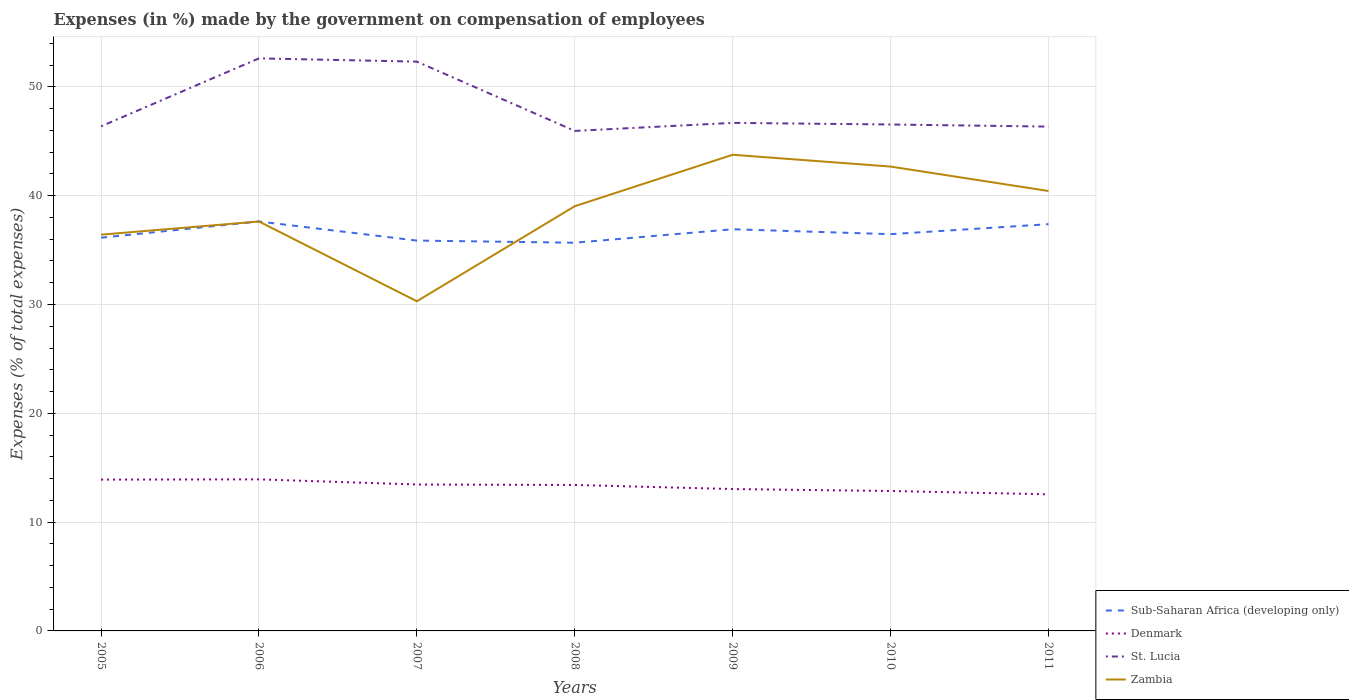How many different coloured lines are there?
Make the answer very short. 4. Is the number of lines equal to the number of legend labels?
Give a very brief answer. Yes. Across all years, what is the maximum percentage of expenses made by the government on compensation of employees in Sub-Saharan Africa (developing only)?
Make the answer very short. 35.68. In which year was the percentage of expenses made by the government on compensation of employees in Sub-Saharan Africa (developing only) maximum?
Provide a short and direct response. 2008. What is the total percentage of expenses made by the government on compensation of employees in St. Lucia in the graph?
Your answer should be compact. -0.17. What is the difference between the highest and the second highest percentage of expenses made by the government on compensation of employees in St. Lucia?
Your answer should be very brief. 6.67. What is the difference between the highest and the lowest percentage of expenses made by the government on compensation of employees in Denmark?
Ensure brevity in your answer.  4. How many years are there in the graph?
Provide a succinct answer. 7. Are the values on the major ticks of Y-axis written in scientific E-notation?
Provide a short and direct response. No. Does the graph contain grids?
Provide a succinct answer. Yes. How many legend labels are there?
Keep it short and to the point. 4. How are the legend labels stacked?
Make the answer very short. Vertical. What is the title of the graph?
Offer a very short reply. Expenses (in %) made by the government on compensation of employees. Does "Liechtenstein" appear as one of the legend labels in the graph?
Your answer should be very brief. No. What is the label or title of the X-axis?
Give a very brief answer. Years. What is the label or title of the Y-axis?
Provide a short and direct response. Expenses (% of total expenses). What is the Expenses (% of total expenses) in Sub-Saharan Africa (developing only) in 2005?
Your response must be concise. 36.14. What is the Expenses (% of total expenses) in Denmark in 2005?
Ensure brevity in your answer.  13.91. What is the Expenses (% of total expenses) of St. Lucia in 2005?
Ensure brevity in your answer.  46.38. What is the Expenses (% of total expenses) of Zambia in 2005?
Your answer should be compact. 36.42. What is the Expenses (% of total expenses) of Sub-Saharan Africa (developing only) in 2006?
Provide a succinct answer. 37.63. What is the Expenses (% of total expenses) in Denmark in 2006?
Provide a succinct answer. 13.93. What is the Expenses (% of total expenses) in St. Lucia in 2006?
Keep it short and to the point. 52.62. What is the Expenses (% of total expenses) in Zambia in 2006?
Keep it short and to the point. 37.63. What is the Expenses (% of total expenses) of Sub-Saharan Africa (developing only) in 2007?
Give a very brief answer. 35.87. What is the Expenses (% of total expenses) of Denmark in 2007?
Offer a very short reply. 13.46. What is the Expenses (% of total expenses) in St. Lucia in 2007?
Offer a terse response. 52.32. What is the Expenses (% of total expenses) of Zambia in 2007?
Make the answer very short. 30.3. What is the Expenses (% of total expenses) of Sub-Saharan Africa (developing only) in 2008?
Make the answer very short. 35.68. What is the Expenses (% of total expenses) of Denmark in 2008?
Your answer should be very brief. 13.41. What is the Expenses (% of total expenses) of St. Lucia in 2008?
Keep it short and to the point. 45.95. What is the Expenses (% of total expenses) of Zambia in 2008?
Provide a succinct answer. 39.03. What is the Expenses (% of total expenses) in Sub-Saharan Africa (developing only) in 2009?
Your answer should be very brief. 36.91. What is the Expenses (% of total expenses) of Denmark in 2009?
Your response must be concise. 13.04. What is the Expenses (% of total expenses) in St. Lucia in 2009?
Provide a short and direct response. 46.69. What is the Expenses (% of total expenses) of Zambia in 2009?
Your answer should be compact. 43.76. What is the Expenses (% of total expenses) of Sub-Saharan Africa (developing only) in 2010?
Your answer should be very brief. 36.46. What is the Expenses (% of total expenses) of Denmark in 2010?
Your response must be concise. 12.86. What is the Expenses (% of total expenses) of St. Lucia in 2010?
Ensure brevity in your answer.  46.54. What is the Expenses (% of total expenses) in Zambia in 2010?
Make the answer very short. 42.68. What is the Expenses (% of total expenses) in Sub-Saharan Africa (developing only) in 2011?
Offer a very short reply. 37.38. What is the Expenses (% of total expenses) of Denmark in 2011?
Offer a very short reply. 12.55. What is the Expenses (% of total expenses) of St. Lucia in 2011?
Keep it short and to the point. 46.35. What is the Expenses (% of total expenses) of Zambia in 2011?
Ensure brevity in your answer.  40.43. Across all years, what is the maximum Expenses (% of total expenses) of Sub-Saharan Africa (developing only)?
Offer a very short reply. 37.63. Across all years, what is the maximum Expenses (% of total expenses) of Denmark?
Offer a terse response. 13.93. Across all years, what is the maximum Expenses (% of total expenses) in St. Lucia?
Give a very brief answer. 52.62. Across all years, what is the maximum Expenses (% of total expenses) in Zambia?
Ensure brevity in your answer.  43.76. Across all years, what is the minimum Expenses (% of total expenses) in Sub-Saharan Africa (developing only)?
Offer a terse response. 35.68. Across all years, what is the minimum Expenses (% of total expenses) in Denmark?
Your response must be concise. 12.55. Across all years, what is the minimum Expenses (% of total expenses) in St. Lucia?
Keep it short and to the point. 45.95. Across all years, what is the minimum Expenses (% of total expenses) in Zambia?
Provide a succinct answer. 30.3. What is the total Expenses (% of total expenses) of Sub-Saharan Africa (developing only) in the graph?
Ensure brevity in your answer.  256.08. What is the total Expenses (% of total expenses) in Denmark in the graph?
Provide a succinct answer. 93.16. What is the total Expenses (% of total expenses) of St. Lucia in the graph?
Keep it short and to the point. 336.85. What is the total Expenses (% of total expenses) of Zambia in the graph?
Your response must be concise. 270.25. What is the difference between the Expenses (% of total expenses) of Sub-Saharan Africa (developing only) in 2005 and that in 2006?
Make the answer very short. -1.49. What is the difference between the Expenses (% of total expenses) of Denmark in 2005 and that in 2006?
Your answer should be very brief. -0.02. What is the difference between the Expenses (% of total expenses) of St. Lucia in 2005 and that in 2006?
Provide a short and direct response. -6.24. What is the difference between the Expenses (% of total expenses) in Zambia in 2005 and that in 2006?
Make the answer very short. -1.21. What is the difference between the Expenses (% of total expenses) in Sub-Saharan Africa (developing only) in 2005 and that in 2007?
Your answer should be compact. 0.26. What is the difference between the Expenses (% of total expenses) of Denmark in 2005 and that in 2007?
Give a very brief answer. 0.45. What is the difference between the Expenses (% of total expenses) of St. Lucia in 2005 and that in 2007?
Provide a short and direct response. -5.95. What is the difference between the Expenses (% of total expenses) of Zambia in 2005 and that in 2007?
Provide a succinct answer. 6.12. What is the difference between the Expenses (% of total expenses) of Sub-Saharan Africa (developing only) in 2005 and that in 2008?
Offer a very short reply. 0.46. What is the difference between the Expenses (% of total expenses) of Denmark in 2005 and that in 2008?
Make the answer very short. 0.49. What is the difference between the Expenses (% of total expenses) of St. Lucia in 2005 and that in 2008?
Give a very brief answer. 0.42. What is the difference between the Expenses (% of total expenses) of Zambia in 2005 and that in 2008?
Provide a short and direct response. -2.62. What is the difference between the Expenses (% of total expenses) in Sub-Saharan Africa (developing only) in 2005 and that in 2009?
Your response must be concise. -0.78. What is the difference between the Expenses (% of total expenses) of Denmark in 2005 and that in 2009?
Make the answer very short. 0.87. What is the difference between the Expenses (% of total expenses) of St. Lucia in 2005 and that in 2009?
Keep it short and to the point. -0.31. What is the difference between the Expenses (% of total expenses) of Zambia in 2005 and that in 2009?
Give a very brief answer. -7.34. What is the difference between the Expenses (% of total expenses) of Sub-Saharan Africa (developing only) in 2005 and that in 2010?
Your response must be concise. -0.33. What is the difference between the Expenses (% of total expenses) of Denmark in 2005 and that in 2010?
Your answer should be very brief. 1.05. What is the difference between the Expenses (% of total expenses) in St. Lucia in 2005 and that in 2010?
Keep it short and to the point. -0.17. What is the difference between the Expenses (% of total expenses) in Zambia in 2005 and that in 2010?
Make the answer very short. -6.26. What is the difference between the Expenses (% of total expenses) in Sub-Saharan Africa (developing only) in 2005 and that in 2011?
Provide a short and direct response. -1.24. What is the difference between the Expenses (% of total expenses) in Denmark in 2005 and that in 2011?
Your answer should be compact. 1.35. What is the difference between the Expenses (% of total expenses) in St. Lucia in 2005 and that in 2011?
Offer a terse response. 0.03. What is the difference between the Expenses (% of total expenses) in Zambia in 2005 and that in 2011?
Keep it short and to the point. -4.01. What is the difference between the Expenses (% of total expenses) in Sub-Saharan Africa (developing only) in 2006 and that in 2007?
Give a very brief answer. 1.75. What is the difference between the Expenses (% of total expenses) of Denmark in 2006 and that in 2007?
Offer a terse response. 0.47. What is the difference between the Expenses (% of total expenses) in St. Lucia in 2006 and that in 2007?
Your answer should be very brief. 0.3. What is the difference between the Expenses (% of total expenses) of Zambia in 2006 and that in 2007?
Offer a very short reply. 7.33. What is the difference between the Expenses (% of total expenses) in Sub-Saharan Africa (developing only) in 2006 and that in 2008?
Make the answer very short. 1.95. What is the difference between the Expenses (% of total expenses) of Denmark in 2006 and that in 2008?
Your response must be concise. 0.52. What is the difference between the Expenses (% of total expenses) of St. Lucia in 2006 and that in 2008?
Your answer should be compact. 6.67. What is the difference between the Expenses (% of total expenses) in Zambia in 2006 and that in 2008?
Offer a very short reply. -1.41. What is the difference between the Expenses (% of total expenses) of Sub-Saharan Africa (developing only) in 2006 and that in 2009?
Make the answer very short. 0.71. What is the difference between the Expenses (% of total expenses) of Denmark in 2006 and that in 2009?
Give a very brief answer. 0.89. What is the difference between the Expenses (% of total expenses) of St. Lucia in 2006 and that in 2009?
Your answer should be very brief. 5.93. What is the difference between the Expenses (% of total expenses) of Zambia in 2006 and that in 2009?
Your answer should be compact. -6.13. What is the difference between the Expenses (% of total expenses) in Sub-Saharan Africa (developing only) in 2006 and that in 2010?
Provide a succinct answer. 1.16. What is the difference between the Expenses (% of total expenses) in Denmark in 2006 and that in 2010?
Your answer should be very brief. 1.07. What is the difference between the Expenses (% of total expenses) of St. Lucia in 2006 and that in 2010?
Keep it short and to the point. 6.08. What is the difference between the Expenses (% of total expenses) in Zambia in 2006 and that in 2010?
Your answer should be compact. -5.05. What is the difference between the Expenses (% of total expenses) of Sub-Saharan Africa (developing only) in 2006 and that in 2011?
Provide a short and direct response. 0.25. What is the difference between the Expenses (% of total expenses) of Denmark in 2006 and that in 2011?
Your answer should be compact. 1.37. What is the difference between the Expenses (% of total expenses) in St. Lucia in 2006 and that in 2011?
Make the answer very short. 6.27. What is the difference between the Expenses (% of total expenses) of Zambia in 2006 and that in 2011?
Offer a very short reply. -2.8. What is the difference between the Expenses (% of total expenses) in Sub-Saharan Africa (developing only) in 2007 and that in 2008?
Your answer should be compact. 0.2. What is the difference between the Expenses (% of total expenses) in Denmark in 2007 and that in 2008?
Offer a very short reply. 0.04. What is the difference between the Expenses (% of total expenses) in St. Lucia in 2007 and that in 2008?
Offer a terse response. 6.37. What is the difference between the Expenses (% of total expenses) in Zambia in 2007 and that in 2008?
Ensure brevity in your answer.  -8.74. What is the difference between the Expenses (% of total expenses) in Sub-Saharan Africa (developing only) in 2007 and that in 2009?
Your answer should be very brief. -1.04. What is the difference between the Expenses (% of total expenses) in Denmark in 2007 and that in 2009?
Keep it short and to the point. 0.42. What is the difference between the Expenses (% of total expenses) in St. Lucia in 2007 and that in 2009?
Your answer should be compact. 5.63. What is the difference between the Expenses (% of total expenses) in Zambia in 2007 and that in 2009?
Offer a terse response. -13.46. What is the difference between the Expenses (% of total expenses) in Sub-Saharan Africa (developing only) in 2007 and that in 2010?
Offer a terse response. -0.59. What is the difference between the Expenses (% of total expenses) of Denmark in 2007 and that in 2010?
Offer a very short reply. 0.6. What is the difference between the Expenses (% of total expenses) of St. Lucia in 2007 and that in 2010?
Give a very brief answer. 5.78. What is the difference between the Expenses (% of total expenses) of Zambia in 2007 and that in 2010?
Your answer should be compact. -12.38. What is the difference between the Expenses (% of total expenses) in Sub-Saharan Africa (developing only) in 2007 and that in 2011?
Your response must be concise. -1.51. What is the difference between the Expenses (% of total expenses) in Denmark in 2007 and that in 2011?
Ensure brevity in your answer.  0.9. What is the difference between the Expenses (% of total expenses) in St. Lucia in 2007 and that in 2011?
Provide a succinct answer. 5.97. What is the difference between the Expenses (% of total expenses) of Zambia in 2007 and that in 2011?
Offer a very short reply. -10.13. What is the difference between the Expenses (% of total expenses) in Sub-Saharan Africa (developing only) in 2008 and that in 2009?
Offer a very short reply. -1.24. What is the difference between the Expenses (% of total expenses) in Denmark in 2008 and that in 2009?
Give a very brief answer. 0.38. What is the difference between the Expenses (% of total expenses) of St. Lucia in 2008 and that in 2009?
Ensure brevity in your answer.  -0.74. What is the difference between the Expenses (% of total expenses) of Zambia in 2008 and that in 2009?
Your answer should be very brief. -4.73. What is the difference between the Expenses (% of total expenses) in Sub-Saharan Africa (developing only) in 2008 and that in 2010?
Your response must be concise. -0.79. What is the difference between the Expenses (% of total expenses) in Denmark in 2008 and that in 2010?
Your answer should be compact. 0.55. What is the difference between the Expenses (% of total expenses) of St. Lucia in 2008 and that in 2010?
Your response must be concise. -0.59. What is the difference between the Expenses (% of total expenses) in Zambia in 2008 and that in 2010?
Provide a short and direct response. -3.64. What is the difference between the Expenses (% of total expenses) of Sub-Saharan Africa (developing only) in 2008 and that in 2011?
Your response must be concise. -1.7. What is the difference between the Expenses (% of total expenses) of Denmark in 2008 and that in 2011?
Provide a short and direct response. 0.86. What is the difference between the Expenses (% of total expenses) in St. Lucia in 2008 and that in 2011?
Provide a succinct answer. -0.4. What is the difference between the Expenses (% of total expenses) of Zambia in 2008 and that in 2011?
Ensure brevity in your answer.  -1.4. What is the difference between the Expenses (% of total expenses) in Sub-Saharan Africa (developing only) in 2009 and that in 2010?
Give a very brief answer. 0.45. What is the difference between the Expenses (% of total expenses) in Denmark in 2009 and that in 2010?
Keep it short and to the point. 0.18. What is the difference between the Expenses (% of total expenses) in St. Lucia in 2009 and that in 2010?
Your answer should be compact. 0.15. What is the difference between the Expenses (% of total expenses) of Zambia in 2009 and that in 2010?
Provide a short and direct response. 1.08. What is the difference between the Expenses (% of total expenses) of Sub-Saharan Africa (developing only) in 2009 and that in 2011?
Your answer should be very brief. -0.47. What is the difference between the Expenses (% of total expenses) in Denmark in 2009 and that in 2011?
Give a very brief answer. 0.48. What is the difference between the Expenses (% of total expenses) of St. Lucia in 2009 and that in 2011?
Provide a succinct answer. 0.34. What is the difference between the Expenses (% of total expenses) in Zambia in 2009 and that in 2011?
Your answer should be very brief. 3.33. What is the difference between the Expenses (% of total expenses) in Sub-Saharan Africa (developing only) in 2010 and that in 2011?
Provide a succinct answer. -0.92. What is the difference between the Expenses (% of total expenses) of Denmark in 2010 and that in 2011?
Provide a succinct answer. 0.31. What is the difference between the Expenses (% of total expenses) of St. Lucia in 2010 and that in 2011?
Provide a short and direct response. 0.19. What is the difference between the Expenses (% of total expenses) of Zambia in 2010 and that in 2011?
Offer a very short reply. 2.24. What is the difference between the Expenses (% of total expenses) of Sub-Saharan Africa (developing only) in 2005 and the Expenses (% of total expenses) of Denmark in 2006?
Offer a very short reply. 22.21. What is the difference between the Expenses (% of total expenses) in Sub-Saharan Africa (developing only) in 2005 and the Expenses (% of total expenses) in St. Lucia in 2006?
Make the answer very short. -16.48. What is the difference between the Expenses (% of total expenses) in Sub-Saharan Africa (developing only) in 2005 and the Expenses (% of total expenses) in Zambia in 2006?
Your answer should be very brief. -1.49. What is the difference between the Expenses (% of total expenses) in Denmark in 2005 and the Expenses (% of total expenses) in St. Lucia in 2006?
Your answer should be very brief. -38.71. What is the difference between the Expenses (% of total expenses) in Denmark in 2005 and the Expenses (% of total expenses) in Zambia in 2006?
Provide a succinct answer. -23.72. What is the difference between the Expenses (% of total expenses) in St. Lucia in 2005 and the Expenses (% of total expenses) in Zambia in 2006?
Ensure brevity in your answer.  8.75. What is the difference between the Expenses (% of total expenses) of Sub-Saharan Africa (developing only) in 2005 and the Expenses (% of total expenses) of Denmark in 2007?
Ensure brevity in your answer.  22.68. What is the difference between the Expenses (% of total expenses) in Sub-Saharan Africa (developing only) in 2005 and the Expenses (% of total expenses) in St. Lucia in 2007?
Offer a terse response. -16.19. What is the difference between the Expenses (% of total expenses) of Sub-Saharan Africa (developing only) in 2005 and the Expenses (% of total expenses) of Zambia in 2007?
Make the answer very short. 5.84. What is the difference between the Expenses (% of total expenses) of Denmark in 2005 and the Expenses (% of total expenses) of St. Lucia in 2007?
Ensure brevity in your answer.  -38.41. What is the difference between the Expenses (% of total expenses) of Denmark in 2005 and the Expenses (% of total expenses) of Zambia in 2007?
Make the answer very short. -16.39. What is the difference between the Expenses (% of total expenses) in St. Lucia in 2005 and the Expenses (% of total expenses) in Zambia in 2007?
Give a very brief answer. 16.08. What is the difference between the Expenses (% of total expenses) in Sub-Saharan Africa (developing only) in 2005 and the Expenses (% of total expenses) in Denmark in 2008?
Your answer should be compact. 22.72. What is the difference between the Expenses (% of total expenses) in Sub-Saharan Africa (developing only) in 2005 and the Expenses (% of total expenses) in St. Lucia in 2008?
Provide a succinct answer. -9.81. What is the difference between the Expenses (% of total expenses) in Sub-Saharan Africa (developing only) in 2005 and the Expenses (% of total expenses) in Zambia in 2008?
Give a very brief answer. -2.9. What is the difference between the Expenses (% of total expenses) in Denmark in 2005 and the Expenses (% of total expenses) in St. Lucia in 2008?
Provide a short and direct response. -32.04. What is the difference between the Expenses (% of total expenses) in Denmark in 2005 and the Expenses (% of total expenses) in Zambia in 2008?
Provide a short and direct response. -25.13. What is the difference between the Expenses (% of total expenses) of St. Lucia in 2005 and the Expenses (% of total expenses) of Zambia in 2008?
Your answer should be very brief. 7.34. What is the difference between the Expenses (% of total expenses) in Sub-Saharan Africa (developing only) in 2005 and the Expenses (% of total expenses) in Denmark in 2009?
Give a very brief answer. 23.1. What is the difference between the Expenses (% of total expenses) of Sub-Saharan Africa (developing only) in 2005 and the Expenses (% of total expenses) of St. Lucia in 2009?
Offer a terse response. -10.55. What is the difference between the Expenses (% of total expenses) in Sub-Saharan Africa (developing only) in 2005 and the Expenses (% of total expenses) in Zambia in 2009?
Your answer should be very brief. -7.62. What is the difference between the Expenses (% of total expenses) of Denmark in 2005 and the Expenses (% of total expenses) of St. Lucia in 2009?
Keep it short and to the point. -32.78. What is the difference between the Expenses (% of total expenses) in Denmark in 2005 and the Expenses (% of total expenses) in Zambia in 2009?
Offer a terse response. -29.85. What is the difference between the Expenses (% of total expenses) in St. Lucia in 2005 and the Expenses (% of total expenses) in Zambia in 2009?
Your answer should be very brief. 2.62. What is the difference between the Expenses (% of total expenses) of Sub-Saharan Africa (developing only) in 2005 and the Expenses (% of total expenses) of Denmark in 2010?
Your answer should be compact. 23.28. What is the difference between the Expenses (% of total expenses) of Sub-Saharan Africa (developing only) in 2005 and the Expenses (% of total expenses) of St. Lucia in 2010?
Give a very brief answer. -10.41. What is the difference between the Expenses (% of total expenses) in Sub-Saharan Africa (developing only) in 2005 and the Expenses (% of total expenses) in Zambia in 2010?
Make the answer very short. -6.54. What is the difference between the Expenses (% of total expenses) in Denmark in 2005 and the Expenses (% of total expenses) in St. Lucia in 2010?
Keep it short and to the point. -32.64. What is the difference between the Expenses (% of total expenses) in Denmark in 2005 and the Expenses (% of total expenses) in Zambia in 2010?
Your answer should be very brief. -28.77. What is the difference between the Expenses (% of total expenses) in St. Lucia in 2005 and the Expenses (% of total expenses) in Zambia in 2010?
Provide a succinct answer. 3.7. What is the difference between the Expenses (% of total expenses) of Sub-Saharan Africa (developing only) in 2005 and the Expenses (% of total expenses) of Denmark in 2011?
Make the answer very short. 23.58. What is the difference between the Expenses (% of total expenses) of Sub-Saharan Africa (developing only) in 2005 and the Expenses (% of total expenses) of St. Lucia in 2011?
Your answer should be very brief. -10.21. What is the difference between the Expenses (% of total expenses) of Sub-Saharan Africa (developing only) in 2005 and the Expenses (% of total expenses) of Zambia in 2011?
Ensure brevity in your answer.  -4.29. What is the difference between the Expenses (% of total expenses) in Denmark in 2005 and the Expenses (% of total expenses) in St. Lucia in 2011?
Provide a short and direct response. -32.44. What is the difference between the Expenses (% of total expenses) in Denmark in 2005 and the Expenses (% of total expenses) in Zambia in 2011?
Make the answer very short. -26.52. What is the difference between the Expenses (% of total expenses) of St. Lucia in 2005 and the Expenses (% of total expenses) of Zambia in 2011?
Your response must be concise. 5.95. What is the difference between the Expenses (% of total expenses) in Sub-Saharan Africa (developing only) in 2006 and the Expenses (% of total expenses) in Denmark in 2007?
Offer a very short reply. 24.17. What is the difference between the Expenses (% of total expenses) of Sub-Saharan Africa (developing only) in 2006 and the Expenses (% of total expenses) of St. Lucia in 2007?
Provide a succinct answer. -14.69. What is the difference between the Expenses (% of total expenses) of Sub-Saharan Africa (developing only) in 2006 and the Expenses (% of total expenses) of Zambia in 2007?
Provide a succinct answer. 7.33. What is the difference between the Expenses (% of total expenses) of Denmark in 2006 and the Expenses (% of total expenses) of St. Lucia in 2007?
Offer a very short reply. -38.39. What is the difference between the Expenses (% of total expenses) in Denmark in 2006 and the Expenses (% of total expenses) in Zambia in 2007?
Your response must be concise. -16.37. What is the difference between the Expenses (% of total expenses) of St. Lucia in 2006 and the Expenses (% of total expenses) of Zambia in 2007?
Make the answer very short. 22.32. What is the difference between the Expenses (% of total expenses) in Sub-Saharan Africa (developing only) in 2006 and the Expenses (% of total expenses) in Denmark in 2008?
Ensure brevity in your answer.  24.21. What is the difference between the Expenses (% of total expenses) of Sub-Saharan Africa (developing only) in 2006 and the Expenses (% of total expenses) of St. Lucia in 2008?
Your response must be concise. -8.32. What is the difference between the Expenses (% of total expenses) of Sub-Saharan Africa (developing only) in 2006 and the Expenses (% of total expenses) of Zambia in 2008?
Ensure brevity in your answer.  -1.41. What is the difference between the Expenses (% of total expenses) of Denmark in 2006 and the Expenses (% of total expenses) of St. Lucia in 2008?
Give a very brief answer. -32.02. What is the difference between the Expenses (% of total expenses) in Denmark in 2006 and the Expenses (% of total expenses) in Zambia in 2008?
Offer a very short reply. -25.11. What is the difference between the Expenses (% of total expenses) in St. Lucia in 2006 and the Expenses (% of total expenses) in Zambia in 2008?
Offer a terse response. 13.58. What is the difference between the Expenses (% of total expenses) in Sub-Saharan Africa (developing only) in 2006 and the Expenses (% of total expenses) in Denmark in 2009?
Keep it short and to the point. 24.59. What is the difference between the Expenses (% of total expenses) of Sub-Saharan Africa (developing only) in 2006 and the Expenses (% of total expenses) of St. Lucia in 2009?
Your answer should be compact. -9.06. What is the difference between the Expenses (% of total expenses) of Sub-Saharan Africa (developing only) in 2006 and the Expenses (% of total expenses) of Zambia in 2009?
Your answer should be compact. -6.13. What is the difference between the Expenses (% of total expenses) of Denmark in 2006 and the Expenses (% of total expenses) of St. Lucia in 2009?
Provide a short and direct response. -32.76. What is the difference between the Expenses (% of total expenses) in Denmark in 2006 and the Expenses (% of total expenses) in Zambia in 2009?
Your answer should be compact. -29.83. What is the difference between the Expenses (% of total expenses) in St. Lucia in 2006 and the Expenses (% of total expenses) in Zambia in 2009?
Make the answer very short. 8.86. What is the difference between the Expenses (% of total expenses) in Sub-Saharan Africa (developing only) in 2006 and the Expenses (% of total expenses) in Denmark in 2010?
Ensure brevity in your answer.  24.77. What is the difference between the Expenses (% of total expenses) in Sub-Saharan Africa (developing only) in 2006 and the Expenses (% of total expenses) in St. Lucia in 2010?
Keep it short and to the point. -8.91. What is the difference between the Expenses (% of total expenses) in Sub-Saharan Africa (developing only) in 2006 and the Expenses (% of total expenses) in Zambia in 2010?
Give a very brief answer. -5.05. What is the difference between the Expenses (% of total expenses) of Denmark in 2006 and the Expenses (% of total expenses) of St. Lucia in 2010?
Provide a short and direct response. -32.61. What is the difference between the Expenses (% of total expenses) of Denmark in 2006 and the Expenses (% of total expenses) of Zambia in 2010?
Provide a succinct answer. -28.75. What is the difference between the Expenses (% of total expenses) of St. Lucia in 2006 and the Expenses (% of total expenses) of Zambia in 2010?
Your answer should be compact. 9.94. What is the difference between the Expenses (% of total expenses) of Sub-Saharan Africa (developing only) in 2006 and the Expenses (% of total expenses) of Denmark in 2011?
Your response must be concise. 25.07. What is the difference between the Expenses (% of total expenses) of Sub-Saharan Africa (developing only) in 2006 and the Expenses (% of total expenses) of St. Lucia in 2011?
Your response must be concise. -8.72. What is the difference between the Expenses (% of total expenses) of Sub-Saharan Africa (developing only) in 2006 and the Expenses (% of total expenses) of Zambia in 2011?
Keep it short and to the point. -2.8. What is the difference between the Expenses (% of total expenses) in Denmark in 2006 and the Expenses (% of total expenses) in St. Lucia in 2011?
Provide a short and direct response. -32.42. What is the difference between the Expenses (% of total expenses) in Denmark in 2006 and the Expenses (% of total expenses) in Zambia in 2011?
Your answer should be very brief. -26.5. What is the difference between the Expenses (% of total expenses) in St. Lucia in 2006 and the Expenses (% of total expenses) in Zambia in 2011?
Your answer should be compact. 12.19. What is the difference between the Expenses (% of total expenses) in Sub-Saharan Africa (developing only) in 2007 and the Expenses (% of total expenses) in Denmark in 2008?
Your answer should be very brief. 22.46. What is the difference between the Expenses (% of total expenses) of Sub-Saharan Africa (developing only) in 2007 and the Expenses (% of total expenses) of St. Lucia in 2008?
Your response must be concise. -10.08. What is the difference between the Expenses (% of total expenses) in Sub-Saharan Africa (developing only) in 2007 and the Expenses (% of total expenses) in Zambia in 2008?
Your answer should be very brief. -3.16. What is the difference between the Expenses (% of total expenses) in Denmark in 2007 and the Expenses (% of total expenses) in St. Lucia in 2008?
Give a very brief answer. -32.49. What is the difference between the Expenses (% of total expenses) in Denmark in 2007 and the Expenses (% of total expenses) in Zambia in 2008?
Your answer should be compact. -25.58. What is the difference between the Expenses (% of total expenses) in St. Lucia in 2007 and the Expenses (% of total expenses) in Zambia in 2008?
Offer a very short reply. 13.29. What is the difference between the Expenses (% of total expenses) in Sub-Saharan Africa (developing only) in 2007 and the Expenses (% of total expenses) in Denmark in 2009?
Provide a short and direct response. 22.84. What is the difference between the Expenses (% of total expenses) in Sub-Saharan Africa (developing only) in 2007 and the Expenses (% of total expenses) in St. Lucia in 2009?
Give a very brief answer. -10.82. What is the difference between the Expenses (% of total expenses) in Sub-Saharan Africa (developing only) in 2007 and the Expenses (% of total expenses) in Zambia in 2009?
Give a very brief answer. -7.89. What is the difference between the Expenses (% of total expenses) of Denmark in 2007 and the Expenses (% of total expenses) of St. Lucia in 2009?
Your answer should be compact. -33.23. What is the difference between the Expenses (% of total expenses) in Denmark in 2007 and the Expenses (% of total expenses) in Zambia in 2009?
Provide a succinct answer. -30.3. What is the difference between the Expenses (% of total expenses) in St. Lucia in 2007 and the Expenses (% of total expenses) in Zambia in 2009?
Offer a terse response. 8.56. What is the difference between the Expenses (% of total expenses) of Sub-Saharan Africa (developing only) in 2007 and the Expenses (% of total expenses) of Denmark in 2010?
Offer a very short reply. 23.01. What is the difference between the Expenses (% of total expenses) in Sub-Saharan Africa (developing only) in 2007 and the Expenses (% of total expenses) in St. Lucia in 2010?
Provide a short and direct response. -10.67. What is the difference between the Expenses (% of total expenses) in Sub-Saharan Africa (developing only) in 2007 and the Expenses (% of total expenses) in Zambia in 2010?
Your answer should be compact. -6.8. What is the difference between the Expenses (% of total expenses) of Denmark in 2007 and the Expenses (% of total expenses) of St. Lucia in 2010?
Offer a very short reply. -33.09. What is the difference between the Expenses (% of total expenses) in Denmark in 2007 and the Expenses (% of total expenses) in Zambia in 2010?
Offer a very short reply. -29.22. What is the difference between the Expenses (% of total expenses) of St. Lucia in 2007 and the Expenses (% of total expenses) of Zambia in 2010?
Provide a succinct answer. 9.65. What is the difference between the Expenses (% of total expenses) of Sub-Saharan Africa (developing only) in 2007 and the Expenses (% of total expenses) of Denmark in 2011?
Offer a terse response. 23.32. What is the difference between the Expenses (% of total expenses) in Sub-Saharan Africa (developing only) in 2007 and the Expenses (% of total expenses) in St. Lucia in 2011?
Provide a short and direct response. -10.48. What is the difference between the Expenses (% of total expenses) of Sub-Saharan Africa (developing only) in 2007 and the Expenses (% of total expenses) of Zambia in 2011?
Your answer should be very brief. -4.56. What is the difference between the Expenses (% of total expenses) in Denmark in 2007 and the Expenses (% of total expenses) in St. Lucia in 2011?
Provide a succinct answer. -32.89. What is the difference between the Expenses (% of total expenses) in Denmark in 2007 and the Expenses (% of total expenses) in Zambia in 2011?
Provide a succinct answer. -26.97. What is the difference between the Expenses (% of total expenses) of St. Lucia in 2007 and the Expenses (% of total expenses) of Zambia in 2011?
Provide a succinct answer. 11.89. What is the difference between the Expenses (% of total expenses) in Sub-Saharan Africa (developing only) in 2008 and the Expenses (% of total expenses) in Denmark in 2009?
Your answer should be compact. 22.64. What is the difference between the Expenses (% of total expenses) of Sub-Saharan Africa (developing only) in 2008 and the Expenses (% of total expenses) of St. Lucia in 2009?
Offer a very short reply. -11.01. What is the difference between the Expenses (% of total expenses) of Sub-Saharan Africa (developing only) in 2008 and the Expenses (% of total expenses) of Zambia in 2009?
Provide a short and direct response. -8.08. What is the difference between the Expenses (% of total expenses) of Denmark in 2008 and the Expenses (% of total expenses) of St. Lucia in 2009?
Keep it short and to the point. -33.28. What is the difference between the Expenses (% of total expenses) in Denmark in 2008 and the Expenses (% of total expenses) in Zambia in 2009?
Make the answer very short. -30.35. What is the difference between the Expenses (% of total expenses) in St. Lucia in 2008 and the Expenses (% of total expenses) in Zambia in 2009?
Offer a very short reply. 2.19. What is the difference between the Expenses (% of total expenses) in Sub-Saharan Africa (developing only) in 2008 and the Expenses (% of total expenses) in Denmark in 2010?
Your response must be concise. 22.82. What is the difference between the Expenses (% of total expenses) of Sub-Saharan Africa (developing only) in 2008 and the Expenses (% of total expenses) of St. Lucia in 2010?
Your answer should be very brief. -10.87. What is the difference between the Expenses (% of total expenses) of Sub-Saharan Africa (developing only) in 2008 and the Expenses (% of total expenses) of Zambia in 2010?
Offer a terse response. -7. What is the difference between the Expenses (% of total expenses) of Denmark in 2008 and the Expenses (% of total expenses) of St. Lucia in 2010?
Ensure brevity in your answer.  -33.13. What is the difference between the Expenses (% of total expenses) of Denmark in 2008 and the Expenses (% of total expenses) of Zambia in 2010?
Keep it short and to the point. -29.26. What is the difference between the Expenses (% of total expenses) in St. Lucia in 2008 and the Expenses (% of total expenses) in Zambia in 2010?
Keep it short and to the point. 3.28. What is the difference between the Expenses (% of total expenses) of Sub-Saharan Africa (developing only) in 2008 and the Expenses (% of total expenses) of Denmark in 2011?
Offer a very short reply. 23.12. What is the difference between the Expenses (% of total expenses) in Sub-Saharan Africa (developing only) in 2008 and the Expenses (% of total expenses) in St. Lucia in 2011?
Make the answer very short. -10.67. What is the difference between the Expenses (% of total expenses) of Sub-Saharan Africa (developing only) in 2008 and the Expenses (% of total expenses) of Zambia in 2011?
Make the answer very short. -4.75. What is the difference between the Expenses (% of total expenses) in Denmark in 2008 and the Expenses (% of total expenses) in St. Lucia in 2011?
Your answer should be compact. -32.94. What is the difference between the Expenses (% of total expenses) in Denmark in 2008 and the Expenses (% of total expenses) in Zambia in 2011?
Offer a very short reply. -27.02. What is the difference between the Expenses (% of total expenses) in St. Lucia in 2008 and the Expenses (% of total expenses) in Zambia in 2011?
Make the answer very short. 5.52. What is the difference between the Expenses (% of total expenses) in Sub-Saharan Africa (developing only) in 2009 and the Expenses (% of total expenses) in Denmark in 2010?
Ensure brevity in your answer.  24.05. What is the difference between the Expenses (% of total expenses) in Sub-Saharan Africa (developing only) in 2009 and the Expenses (% of total expenses) in St. Lucia in 2010?
Offer a very short reply. -9.63. What is the difference between the Expenses (% of total expenses) of Sub-Saharan Africa (developing only) in 2009 and the Expenses (% of total expenses) of Zambia in 2010?
Keep it short and to the point. -5.76. What is the difference between the Expenses (% of total expenses) of Denmark in 2009 and the Expenses (% of total expenses) of St. Lucia in 2010?
Give a very brief answer. -33.51. What is the difference between the Expenses (% of total expenses) in Denmark in 2009 and the Expenses (% of total expenses) in Zambia in 2010?
Your response must be concise. -29.64. What is the difference between the Expenses (% of total expenses) of St. Lucia in 2009 and the Expenses (% of total expenses) of Zambia in 2010?
Provide a succinct answer. 4.01. What is the difference between the Expenses (% of total expenses) in Sub-Saharan Africa (developing only) in 2009 and the Expenses (% of total expenses) in Denmark in 2011?
Offer a very short reply. 24.36. What is the difference between the Expenses (% of total expenses) in Sub-Saharan Africa (developing only) in 2009 and the Expenses (% of total expenses) in St. Lucia in 2011?
Ensure brevity in your answer.  -9.44. What is the difference between the Expenses (% of total expenses) in Sub-Saharan Africa (developing only) in 2009 and the Expenses (% of total expenses) in Zambia in 2011?
Give a very brief answer. -3.52. What is the difference between the Expenses (% of total expenses) of Denmark in 2009 and the Expenses (% of total expenses) of St. Lucia in 2011?
Provide a succinct answer. -33.31. What is the difference between the Expenses (% of total expenses) of Denmark in 2009 and the Expenses (% of total expenses) of Zambia in 2011?
Offer a terse response. -27.39. What is the difference between the Expenses (% of total expenses) in St. Lucia in 2009 and the Expenses (% of total expenses) in Zambia in 2011?
Offer a terse response. 6.26. What is the difference between the Expenses (% of total expenses) in Sub-Saharan Africa (developing only) in 2010 and the Expenses (% of total expenses) in Denmark in 2011?
Give a very brief answer. 23.91. What is the difference between the Expenses (% of total expenses) of Sub-Saharan Africa (developing only) in 2010 and the Expenses (% of total expenses) of St. Lucia in 2011?
Give a very brief answer. -9.89. What is the difference between the Expenses (% of total expenses) of Sub-Saharan Africa (developing only) in 2010 and the Expenses (% of total expenses) of Zambia in 2011?
Your answer should be very brief. -3.97. What is the difference between the Expenses (% of total expenses) of Denmark in 2010 and the Expenses (% of total expenses) of St. Lucia in 2011?
Provide a succinct answer. -33.49. What is the difference between the Expenses (% of total expenses) of Denmark in 2010 and the Expenses (% of total expenses) of Zambia in 2011?
Offer a very short reply. -27.57. What is the difference between the Expenses (% of total expenses) of St. Lucia in 2010 and the Expenses (% of total expenses) of Zambia in 2011?
Ensure brevity in your answer.  6.11. What is the average Expenses (% of total expenses) of Sub-Saharan Africa (developing only) per year?
Make the answer very short. 36.58. What is the average Expenses (% of total expenses) in Denmark per year?
Your answer should be compact. 13.31. What is the average Expenses (% of total expenses) in St. Lucia per year?
Offer a very short reply. 48.12. What is the average Expenses (% of total expenses) of Zambia per year?
Your answer should be very brief. 38.61. In the year 2005, what is the difference between the Expenses (% of total expenses) of Sub-Saharan Africa (developing only) and Expenses (% of total expenses) of Denmark?
Your answer should be very brief. 22.23. In the year 2005, what is the difference between the Expenses (% of total expenses) in Sub-Saharan Africa (developing only) and Expenses (% of total expenses) in St. Lucia?
Ensure brevity in your answer.  -10.24. In the year 2005, what is the difference between the Expenses (% of total expenses) of Sub-Saharan Africa (developing only) and Expenses (% of total expenses) of Zambia?
Your response must be concise. -0.28. In the year 2005, what is the difference between the Expenses (% of total expenses) in Denmark and Expenses (% of total expenses) in St. Lucia?
Your response must be concise. -32.47. In the year 2005, what is the difference between the Expenses (% of total expenses) of Denmark and Expenses (% of total expenses) of Zambia?
Provide a short and direct response. -22.51. In the year 2005, what is the difference between the Expenses (% of total expenses) in St. Lucia and Expenses (% of total expenses) in Zambia?
Ensure brevity in your answer.  9.96. In the year 2006, what is the difference between the Expenses (% of total expenses) in Sub-Saharan Africa (developing only) and Expenses (% of total expenses) in Denmark?
Make the answer very short. 23.7. In the year 2006, what is the difference between the Expenses (% of total expenses) in Sub-Saharan Africa (developing only) and Expenses (% of total expenses) in St. Lucia?
Ensure brevity in your answer.  -14.99. In the year 2006, what is the difference between the Expenses (% of total expenses) in Denmark and Expenses (% of total expenses) in St. Lucia?
Your answer should be compact. -38.69. In the year 2006, what is the difference between the Expenses (% of total expenses) of Denmark and Expenses (% of total expenses) of Zambia?
Offer a very short reply. -23.7. In the year 2006, what is the difference between the Expenses (% of total expenses) in St. Lucia and Expenses (% of total expenses) in Zambia?
Offer a very short reply. 14.99. In the year 2007, what is the difference between the Expenses (% of total expenses) of Sub-Saharan Africa (developing only) and Expenses (% of total expenses) of Denmark?
Make the answer very short. 22.42. In the year 2007, what is the difference between the Expenses (% of total expenses) of Sub-Saharan Africa (developing only) and Expenses (% of total expenses) of St. Lucia?
Your answer should be very brief. -16.45. In the year 2007, what is the difference between the Expenses (% of total expenses) of Sub-Saharan Africa (developing only) and Expenses (% of total expenses) of Zambia?
Your answer should be compact. 5.57. In the year 2007, what is the difference between the Expenses (% of total expenses) of Denmark and Expenses (% of total expenses) of St. Lucia?
Your answer should be very brief. -38.86. In the year 2007, what is the difference between the Expenses (% of total expenses) of Denmark and Expenses (% of total expenses) of Zambia?
Your answer should be very brief. -16.84. In the year 2007, what is the difference between the Expenses (% of total expenses) in St. Lucia and Expenses (% of total expenses) in Zambia?
Make the answer very short. 22.02. In the year 2008, what is the difference between the Expenses (% of total expenses) of Sub-Saharan Africa (developing only) and Expenses (% of total expenses) of Denmark?
Keep it short and to the point. 22.26. In the year 2008, what is the difference between the Expenses (% of total expenses) in Sub-Saharan Africa (developing only) and Expenses (% of total expenses) in St. Lucia?
Your response must be concise. -10.27. In the year 2008, what is the difference between the Expenses (% of total expenses) in Sub-Saharan Africa (developing only) and Expenses (% of total expenses) in Zambia?
Offer a terse response. -3.36. In the year 2008, what is the difference between the Expenses (% of total expenses) of Denmark and Expenses (% of total expenses) of St. Lucia?
Offer a very short reply. -32.54. In the year 2008, what is the difference between the Expenses (% of total expenses) in Denmark and Expenses (% of total expenses) in Zambia?
Your response must be concise. -25.62. In the year 2008, what is the difference between the Expenses (% of total expenses) of St. Lucia and Expenses (% of total expenses) of Zambia?
Offer a very short reply. 6.92. In the year 2009, what is the difference between the Expenses (% of total expenses) of Sub-Saharan Africa (developing only) and Expenses (% of total expenses) of Denmark?
Give a very brief answer. 23.88. In the year 2009, what is the difference between the Expenses (% of total expenses) in Sub-Saharan Africa (developing only) and Expenses (% of total expenses) in St. Lucia?
Provide a short and direct response. -9.78. In the year 2009, what is the difference between the Expenses (% of total expenses) in Sub-Saharan Africa (developing only) and Expenses (% of total expenses) in Zambia?
Make the answer very short. -6.85. In the year 2009, what is the difference between the Expenses (% of total expenses) in Denmark and Expenses (% of total expenses) in St. Lucia?
Ensure brevity in your answer.  -33.65. In the year 2009, what is the difference between the Expenses (% of total expenses) of Denmark and Expenses (% of total expenses) of Zambia?
Offer a very short reply. -30.72. In the year 2009, what is the difference between the Expenses (% of total expenses) in St. Lucia and Expenses (% of total expenses) in Zambia?
Provide a short and direct response. 2.93. In the year 2010, what is the difference between the Expenses (% of total expenses) in Sub-Saharan Africa (developing only) and Expenses (% of total expenses) in Denmark?
Provide a short and direct response. 23.6. In the year 2010, what is the difference between the Expenses (% of total expenses) of Sub-Saharan Africa (developing only) and Expenses (% of total expenses) of St. Lucia?
Your response must be concise. -10.08. In the year 2010, what is the difference between the Expenses (% of total expenses) of Sub-Saharan Africa (developing only) and Expenses (% of total expenses) of Zambia?
Keep it short and to the point. -6.21. In the year 2010, what is the difference between the Expenses (% of total expenses) of Denmark and Expenses (% of total expenses) of St. Lucia?
Offer a terse response. -33.68. In the year 2010, what is the difference between the Expenses (% of total expenses) in Denmark and Expenses (% of total expenses) in Zambia?
Your response must be concise. -29.82. In the year 2010, what is the difference between the Expenses (% of total expenses) in St. Lucia and Expenses (% of total expenses) in Zambia?
Ensure brevity in your answer.  3.87. In the year 2011, what is the difference between the Expenses (% of total expenses) in Sub-Saharan Africa (developing only) and Expenses (% of total expenses) in Denmark?
Offer a terse response. 24.83. In the year 2011, what is the difference between the Expenses (% of total expenses) in Sub-Saharan Africa (developing only) and Expenses (% of total expenses) in St. Lucia?
Your answer should be very brief. -8.97. In the year 2011, what is the difference between the Expenses (% of total expenses) of Sub-Saharan Africa (developing only) and Expenses (% of total expenses) of Zambia?
Provide a short and direct response. -3.05. In the year 2011, what is the difference between the Expenses (% of total expenses) of Denmark and Expenses (% of total expenses) of St. Lucia?
Offer a terse response. -33.8. In the year 2011, what is the difference between the Expenses (% of total expenses) in Denmark and Expenses (% of total expenses) in Zambia?
Your response must be concise. -27.88. In the year 2011, what is the difference between the Expenses (% of total expenses) in St. Lucia and Expenses (% of total expenses) in Zambia?
Offer a terse response. 5.92. What is the ratio of the Expenses (% of total expenses) of Sub-Saharan Africa (developing only) in 2005 to that in 2006?
Give a very brief answer. 0.96. What is the ratio of the Expenses (% of total expenses) of Denmark in 2005 to that in 2006?
Make the answer very short. 1. What is the ratio of the Expenses (% of total expenses) in St. Lucia in 2005 to that in 2006?
Ensure brevity in your answer.  0.88. What is the ratio of the Expenses (% of total expenses) of Zambia in 2005 to that in 2006?
Give a very brief answer. 0.97. What is the ratio of the Expenses (% of total expenses) in Sub-Saharan Africa (developing only) in 2005 to that in 2007?
Provide a succinct answer. 1.01. What is the ratio of the Expenses (% of total expenses) in Denmark in 2005 to that in 2007?
Your response must be concise. 1.03. What is the ratio of the Expenses (% of total expenses) of St. Lucia in 2005 to that in 2007?
Your answer should be compact. 0.89. What is the ratio of the Expenses (% of total expenses) in Zambia in 2005 to that in 2007?
Your response must be concise. 1.2. What is the ratio of the Expenses (% of total expenses) in Sub-Saharan Africa (developing only) in 2005 to that in 2008?
Keep it short and to the point. 1.01. What is the ratio of the Expenses (% of total expenses) of Denmark in 2005 to that in 2008?
Provide a succinct answer. 1.04. What is the ratio of the Expenses (% of total expenses) of St. Lucia in 2005 to that in 2008?
Give a very brief answer. 1.01. What is the ratio of the Expenses (% of total expenses) in Zambia in 2005 to that in 2008?
Your response must be concise. 0.93. What is the ratio of the Expenses (% of total expenses) in Sub-Saharan Africa (developing only) in 2005 to that in 2009?
Your answer should be very brief. 0.98. What is the ratio of the Expenses (% of total expenses) in Denmark in 2005 to that in 2009?
Give a very brief answer. 1.07. What is the ratio of the Expenses (% of total expenses) in St. Lucia in 2005 to that in 2009?
Make the answer very short. 0.99. What is the ratio of the Expenses (% of total expenses) of Zambia in 2005 to that in 2009?
Make the answer very short. 0.83. What is the ratio of the Expenses (% of total expenses) in Sub-Saharan Africa (developing only) in 2005 to that in 2010?
Provide a succinct answer. 0.99. What is the ratio of the Expenses (% of total expenses) of Denmark in 2005 to that in 2010?
Your answer should be compact. 1.08. What is the ratio of the Expenses (% of total expenses) in Zambia in 2005 to that in 2010?
Give a very brief answer. 0.85. What is the ratio of the Expenses (% of total expenses) in Sub-Saharan Africa (developing only) in 2005 to that in 2011?
Provide a succinct answer. 0.97. What is the ratio of the Expenses (% of total expenses) of Denmark in 2005 to that in 2011?
Your answer should be compact. 1.11. What is the ratio of the Expenses (% of total expenses) in Zambia in 2005 to that in 2011?
Offer a very short reply. 0.9. What is the ratio of the Expenses (% of total expenses) of Sub-Saharan Africa (developing only) in 2006 to that in 2007?
Provide a short and direct response. 1.05. What is the ratio of the Expenses (% of total expenses) in Denmark in 2006 to that in 2007?
Ensure brevity in your answer.  1.03. What is the ratio of the Expenses (% of total expenses) in Zambia in 2006 to that in 2007?
Your answer should be very brief. 1.24. What is the ratio of the Expenses (% of total expenses) in Sub-Saharan Africa (developing only) in 2006 to that in 2008?
Your response must be concise. 1.05. What is the ratio of the Expenses (% of total expenses) of Denmark in 2006 to that in 2008?
Give a very brief answer. 1.04. What is the ratio of the Expenses (% of total expenses) of St. Lucia in 2006 to that in 2008?
Keep it short and to the point. 1.15. What is the ratio of the Expenses (% of total expenses) in Sub-Saharan Africa (developing only) in 2006 to that in 2009?
Provide a succinct answer. 1.02. What is the ratio of the Expenses (% of total expenses) in Denmark in 2006 to that in 2009?
Your answer should be compact. 1.07. What is the ratio of the Expenses (% of total expenses) in St. Lucia in 2006 to that in 2009?
Your answer should be compact. 1.13. What is the ratio of the Expenses (% of total expenses) of Zambia in 2006 to that in 2009?
Keep it short and to the point. 0.86. What is the ratio of the Expenses (% of total expenses) of Sub-Saharan Africa (developing only) in 2006 to that in 2010?
Offer a very short reply. 1.03. What is the ratio of the Expenses (% of total expenses) in Denmark in 2006 to that in 2010?
Offer a terse response. 1.08. What is the ratio of the Expenses (% of total expenses) in St. Lucia in 2006 to that in 2010?
Your response must be concise. 1.13. What is the ratio of the Expenses (% of total expenses) in Zambia in 2006 to that in 2010?
Your answer should be very brief. 0.88. What is the ratio of the Expenses (% of total expenses) in Sub-Saharan Africa (developing only) in 2006 to that in 2011?
Give a very brief answer. 1.01. What is the ratio of the Expenses (% of total expenses) in Denmark in 2006 to that in 2011?
Keep it short and to the point. 1.11. What is the ratio of the Expenses (% of total expenses) in St. Lucia in 2006 to that in 2011?
Ensure brevity in your answer.  1.14. What is the ratio of the Expenses (% of total expenses) of Zambia in 2006 to that in 2011?
Provide a short and direct response. 0.93. What is the ratio of the Expenses (% of total expenses) in Denmark in 2007 to that in 2008?
Make the answer very short. 1. What is the ratio of the Expenses (% of total expenses) of St. Lucia in 2007 to that in 2008?
Make the answer very short. 1.14. What is the ratio of the Expenses (% of total expenses) of Zambia in 2007 to that in 2008?
Provide a short and direct response. 0.78. What is the ratio of the Expenses (% of total expenses) of Sub-Saharan Africa (developing only) in 2007 to that in 2009?
Offer a very short reply. 0.97. What is the ratio of the Expenses (% of total expenses) of Denmark in 2007 to that in 2009?
Your answer should be very brief. 1.03. What is the ratio of the Expenses (% of total expenses) in St. Lucia in 2007 to that in 2009?
Keep it short and to the point. 1.12. What is the ratio of the Expenses (% of total expenses) of Zambia in 2007 to that in 2009?
Your response must be concise. 0.69. What is the ratio of the Expenses (% of total expenses) in Sub-Saharan Africa (developing only) in 2007 to that in 2010?
Make the answer very short. 0.98. What is the ratio of the Expenses (% of total expenses) of Denmark in 2007 to that in 2010?
Provide a succinct answer. 1.05. What is the ratio of the Expenses (% of total expenses) in St. Lucia in 2007 to that in 2010?
Your answer should be very brief. 1.12. What is the ratio of the Expenses (% of total expenses) in Zambia in 2007 to that in 2010?
Keep it short and to the point. 0.71. What is the ratio of the Expenses (% of total expenses) in Sub-Saharan Africa (developing only) in 2007 to that in 2011?
Keep it short and to the point. 0.96. What is the ratio of the Expenses (% of total expenses) in Denmark in 2007 to that in 2011?
Make the answer very short. 1.07. What is the ratio of the Expenses (% of total expenses) in St. Lucia in 2007 to that in 2011?
Ensure brevity in your answer.  1.13. What is the ratio of the Expenses (% of total expenses) of Zambia in 2007 to that in 2011?
Make the answer very short. 0.75. What is the ratio of the Expenses (% of total expenses) in Sub-Saharan Africa (developing only) in 2008 to that in 2009?
Keep it short and to the point. 0.97. What is the ratio of the Expenses (% of total expenses) in Denmark in 2008 to that in 2009?
Offer a very short reply. 1.03. What is the ratio of the Expenses (% of total expenses) in St. Lucia in 2008 to that in 2009?
Provide a succinct answer. 0.98. What is the ratio of the Expenses (% of total expenses) in Zambia in 2008 to that in 2009?
Make the answer very short. 0.89. What is the ratio of the Expenses (% of total expenses) in Sub-Saharan Africa (developing only) in 2008 to that in 2010?
Provide a short and direct response. 0.98. What is the ratio of the Expenses (% of total expenses) in Denmark in 2008 to that in 2010?
Provide a succinct answer. 1.04. What is the ratio of the Expenses (% of total expenses) of St. Lucia in 2008 to that in 2010?
Your answer should be very brief. 0.99. What is the ratio of the Expenses (% of total expenses) of Zambia in 2008 to that in 2010?
Provide a succinct answer. 0.91. What is the ratio of the Expenses (% of total expenses) of Sub-Saharan Africa (developing only) in 2008 to that in 2011?
Provide a succinct answer. 0.95. What is the ratio of the Expenses (% of total expenses) in Denmark in 2008 to that in 2011?
Keep it short and to the point. 1.07. What is the ratio of the Expenses (% of total expenses) of St. Lucia in 2008 to that in 2011?
Ensure brevity in your answer.  0.99. What is the ratio of the Expenses (% of total expenses) in Zambia in 2008 to that in 2011?
Provide a succinct answer. 0.97. What is the ratio of the Expenses (% of total expenses) of Sub-Saharan Africa (developing only) in 2009 to that in 2010?
Provide a succinct answer. 1.01. What is the ratio of the Expenses (% of total expenses) of Denmark in 2009 to that in 2010?
Keep it short and to the point. 1.01. What is the ratio of the Expenses (% of total expenses) of St. Lucia in 2009 to that in 2010?
Provide a short and direct response. 1. What is the ratio of the Expenses (% of total expenses) of Zambia in 2009 to that in 2010?
Your response must be concise. 1.03. What is the ratio of the Expenses (% of total expenses) of Sub-Saharan Africa (developing only) in 2009 to that in 2011?
Make the answer very short. 0.99. What is the ratio of the Expenses (% of total expenses) in Denmark in 2009 to that in 2011?
Ensure brevity in your answer.  1.04. What is the ratio of the Expenses (% of total expenses) in St. Lucia in 2009 to that in 2011?
Keep it short and to the point. 1.01. What is the ratio of the Expenses (% of total expenses) in Zambia in 2009 to that in 2011?
Ensure brevity in your answer.  1.08. What is the ratio of the Expenses (% of total expenses) in Sub-Saharan Africa (developing only) in 2010 to that in 2011?
Ensure brevity in your answer.  0.98. What is the ratio of the Expenses (% of total expenses) of Denmark in 2010 to that in 2011?
Give a very brief answer. 1.02. What is the ratio of the Expenses (% of total expenses) of St. Lucia in 2010 to that in 2011?
Offer a terse response. 1. What is the ratio of the Expenses (% of total expenses) of Zambia in 2010 to that in 2011?
Give a very brief answer. 1.06. What is the difference between the highest and the second highest Expenses (% of total expenses) of Sub-Saharan Africa (developing only)?
Provide a succinct answer. 0.25. What is the difference between the highest and the second highest Expenses (% of total expenses) of Denmark?
Give a very brief answer. 0.02. What is the difference between the highest and the second highest Expenses (% of total expenses) of St. Lucia?
Offer a very short reply. 0.3. What is the difference between the highest and the second highest Expenses (% of total expenses) of Zambia?
Provide a succinct answer. 1.08. What is the difference between the highest and the lowest Expenses (% of total expenses) in Sub-Saharan Africa (developing only)?
Keep it short and to the point. 1.95. What is the difference between the highest and the lowest Expenses (% of total expenses) in Denmark?
Make the answer very short. 1.37. What is the difference between the highest and the lowest Expenses (% of total expenses) of St. Lucia?
Ensure brevity in your answer.  6.67. What is the difference between the highest and the lowest Expenses (% of total expenses) in Zambia?
Offer a terse response. 13.46. 